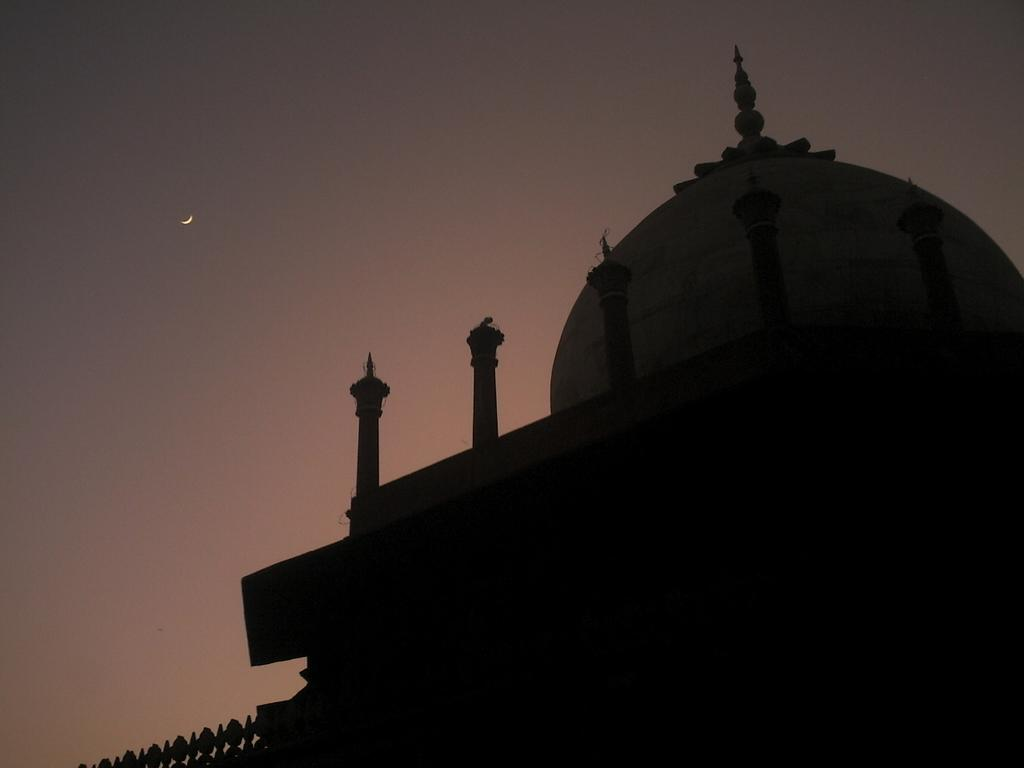What structure is present in the image? There is a building in the image. What celestial body can be seen in the sky in the image? The moon is visible in the sky in the image. What type of mist can be seen surrounding the building in the image? There is no mist present in the image; it only features a building and the moon in the sky. Is there a beggar visible in the image? There is no beggar present in the image. 